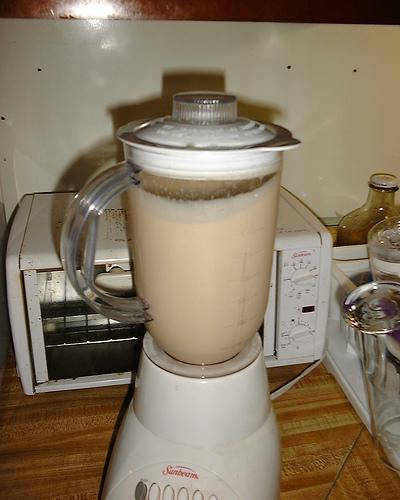Is someone making a milkshake?
Keep it brief. Yes. What tool is seen?
Keep it brief. Blender. What is the brand name of the toaster oven?
Answer briefly. Sunbeam. 